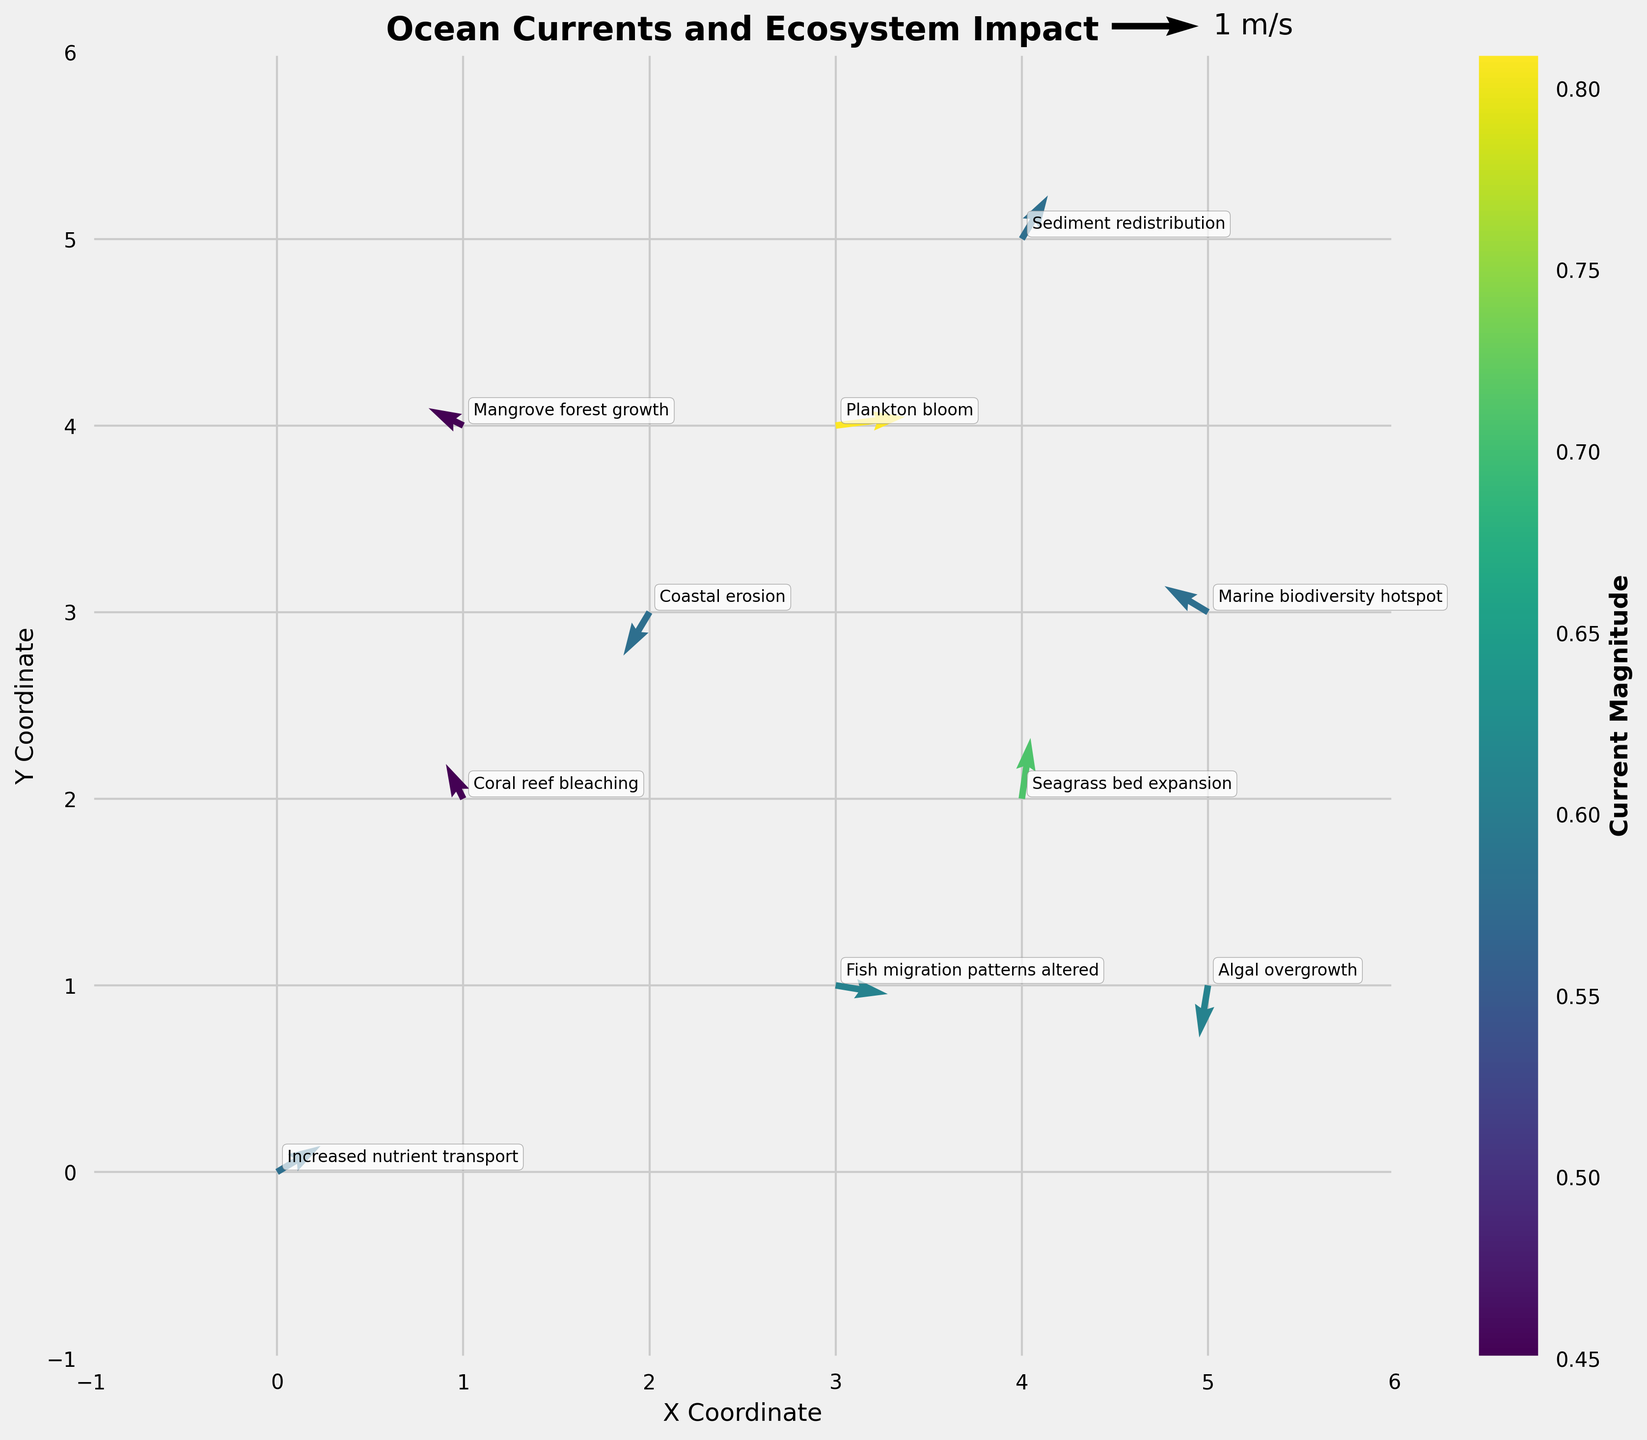what is the title of the plot? The title of the plot is displayed at the top of the figure. It provides an overview of what the plot is about.
Answer: Ocean Currents and Ecosystem Impact How many unique impacts on the coastal ecosystem are annotated in the plot? Count the number of unique impact annotations in the plot.
Answer: 10 Which axis represents the X Coordinate? The X Coordinate is labeled on the horizontal axis of the plot.
Answer: The bottom axis What is the current magnitude range represented by the colorbar? Look at the colorbar beside the plot, which indicates the range of current magnitudes.
Answer: Roughly 0.45 to 0.81 Where does the arrow representing "Coral reef bleaching" start? Locate the annotation for "Coral reef bleaching" and identify the starting X and Y Coordinates of the arrow.
Answer: (1, 2) Comparing "Seagrass bed expansion" and "Algal overgrowth," which one has a higher current magnitude? Check the magnitude values associated with "Seagrass bed expansion" and "Algal overgrowth," then compare.
Answer: Algal overgrowth What vector direction is associated with "Coastal erosion"? Find "Coastal erosion" and identify the direction of the vector by looking at its orientation.
Answer: South-West If you sum the X Coordinates of "Plankton bloom" and "Fish migration patterns altered," what is the result? Add the X coordinates of "Plankton bloom" (3) and "Fish migration patterns altered" (3).
Answer: 6 Which point on the plot corresponds to the highest current magnitude? Look for the point where the color intensity is highest or closest to the maximum value indicated by the colorbar.
Answer: (3, 4) How is the vector direction for "Mangrove forest growth" oriented? Locate "Mangrove forest growth" on the plot and describe the direction of the vector arrow.
Answer: North-West 